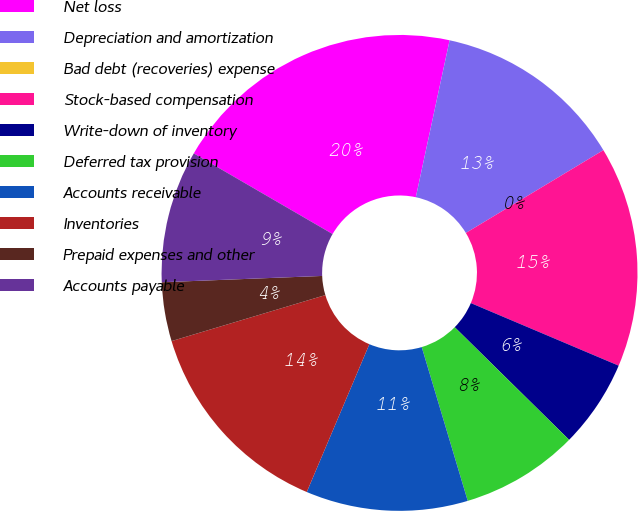Convert chart. <chart><loc_0><loc_0><loc_500><loc_500><pie_chart><fcel>Net loss<fcel>Depreciation and amortization<fcel>Bad debt (recoveries) expense<fcel>Stock-based compensation<fcel>Write-down of inventory<fcel>Deferred tax provision<fcel>Accounts receivable<fcel>Inventories<fcel>Prepaid expenses and other<fcel>Accounts payable<nl><fcel>20.0%<fcel>13.0%<fcel>0.0%<fcel>15.0%<fcel>6.0%<fcel>8.0%<fcel>11.0%<fcel>14.0%<fcel>4.0%<fcel>9.0%<nl></chart> 